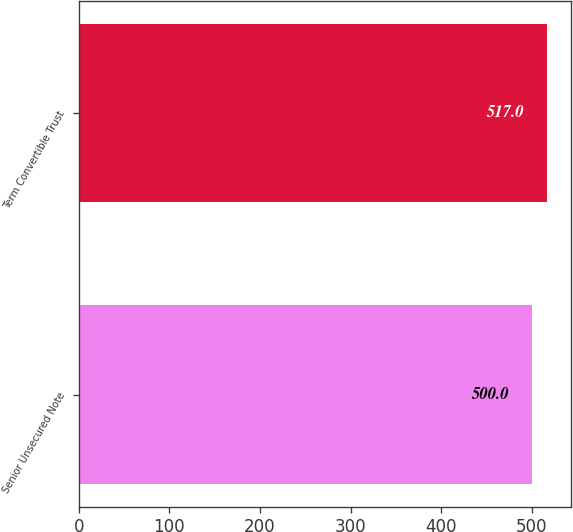Convert chart. <chart><loc_0><loc_0><loc_500><loc_500><bar_chart><fcel>Senior Unsecured Note<fcel>Term Convertible Trust<nl><fcel>500<fcel>517<nl></chart> 